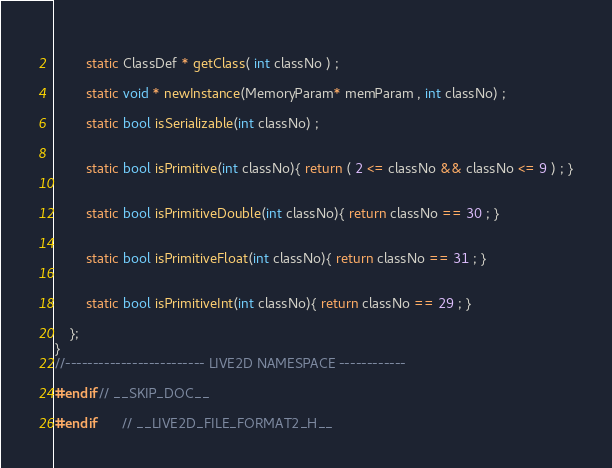<code> <loc_0><loc_0><loc_500><loc_500><_C_>		
		static ClassDef * getClass( int classNo ) ;
		
		static void * newInstance(MemoryParam* memParam , int classNo) ;

		static bool isSerializable(int classNo) ;

		
		static bool isPrimitive(int classNo){ return ( 2 <= classNo && classNo <= 9 ) ; }
	
		
		static bool isPrimitiveDouble(int classNo){ return classNo == 30 ; } 

		
		static bool isPrimitiveFloat(int classNo){ return classNo == 31 ; }

		
		static bool isPrimitiveInt(int classNo){ return classNo == 29 ; }
	
	};
} 
//------------------------- LIVE2D NAMESPACE ------------

#endif // __SKIP_DOC__

#endif		// __LIVE2D_FILE_FORMAT2_H__
</code> 